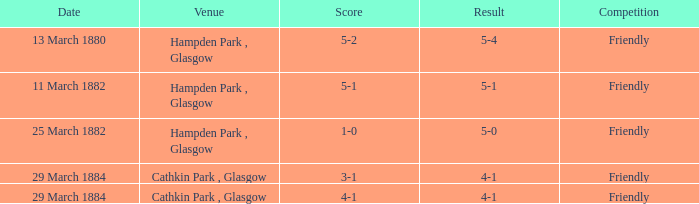Which object has a rating of 5-1? 5-1. 